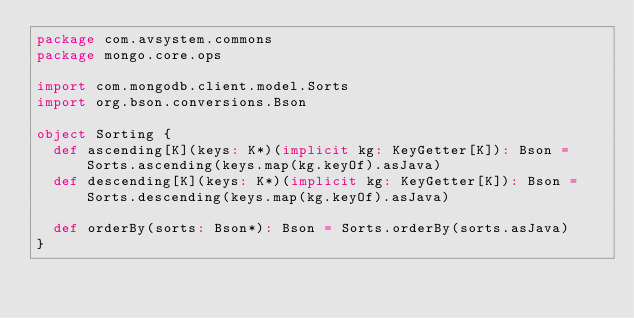<code> <loc_0><loc_0><loc_500><loc_500><_Scala_>package com.avsystem.commons
package mongo.core.ops

import com.mongodb.client.model.Sorts
import org.bson.conversions.Bson

object Sorting {
  def ascending[K](keys: K*)(implicit kg: KeyGetter[K]): Bson = Sorts.ascending(keys.map(kg.keyOf).asJava)
  def descending[K](keys: K*)(implicit kg: KeyGetter[K]): Bson = Sorts.descending(keys.map(kg.keyOf).asJava)

  def orderBy(sorts: Bson*): Bson = Sorts.orderBy(sorts.asJava)
}
</code> 